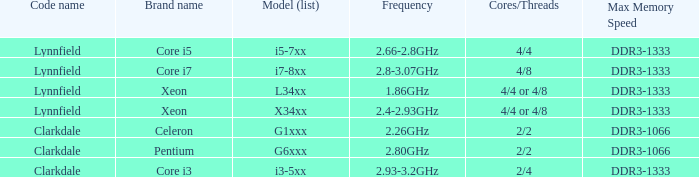What is the operating frequency of model l34xx? 1.86GHz. 